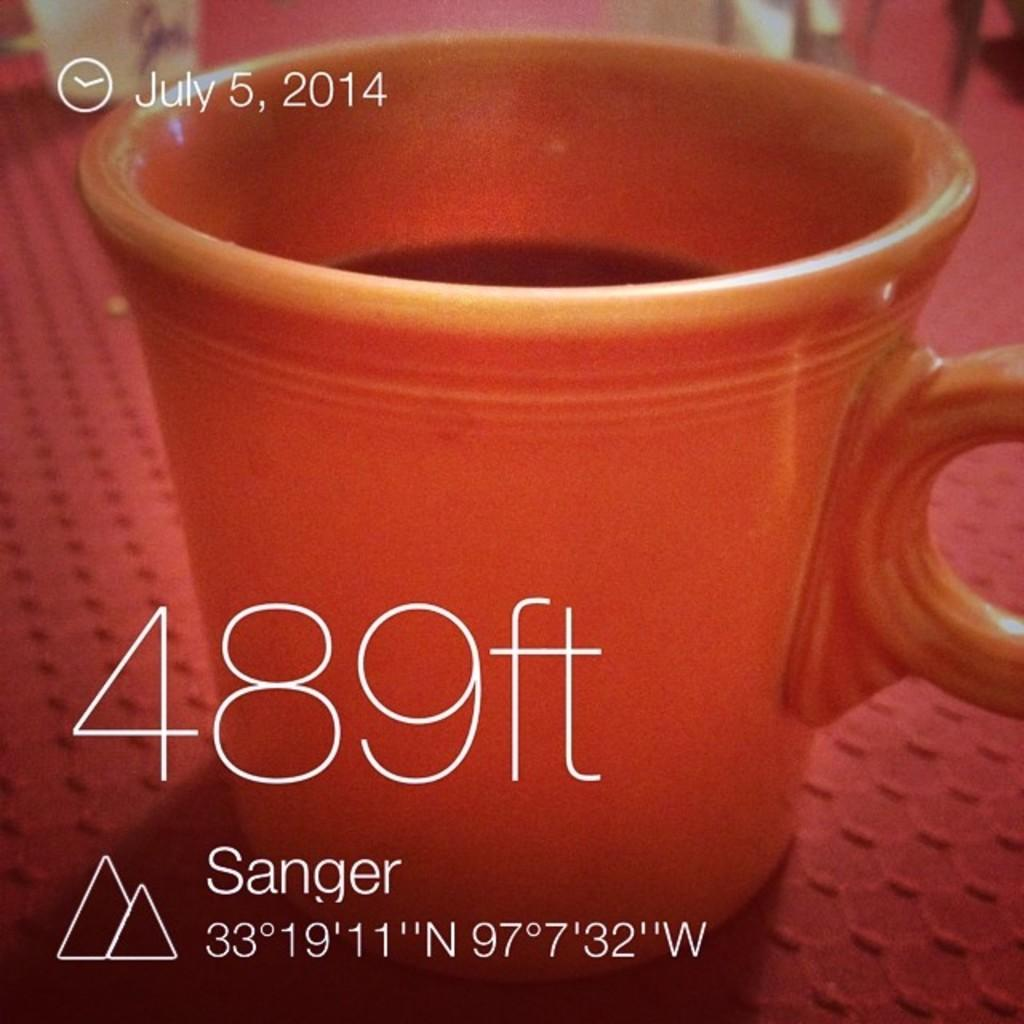<image>
Present a compact description of the photo's key features. A photo of a red coffee cup with the words 489 ft displayed and the date July 5, 2014 